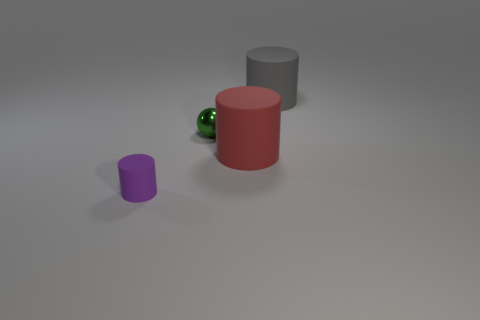Add 1 big brown metallic things. How many objects exist? 5 Subtract all spheres. How many objects are left? 3 Subtract all tiny cylinders. Subtract all big gray objects. How many objects are left? 2 Add 4 green balls. How many green balls are left? 5 Add 3 big gray objects. How many big gray objects exist? 4 Subtract 0 gray cubes. How many objects are left? 4 